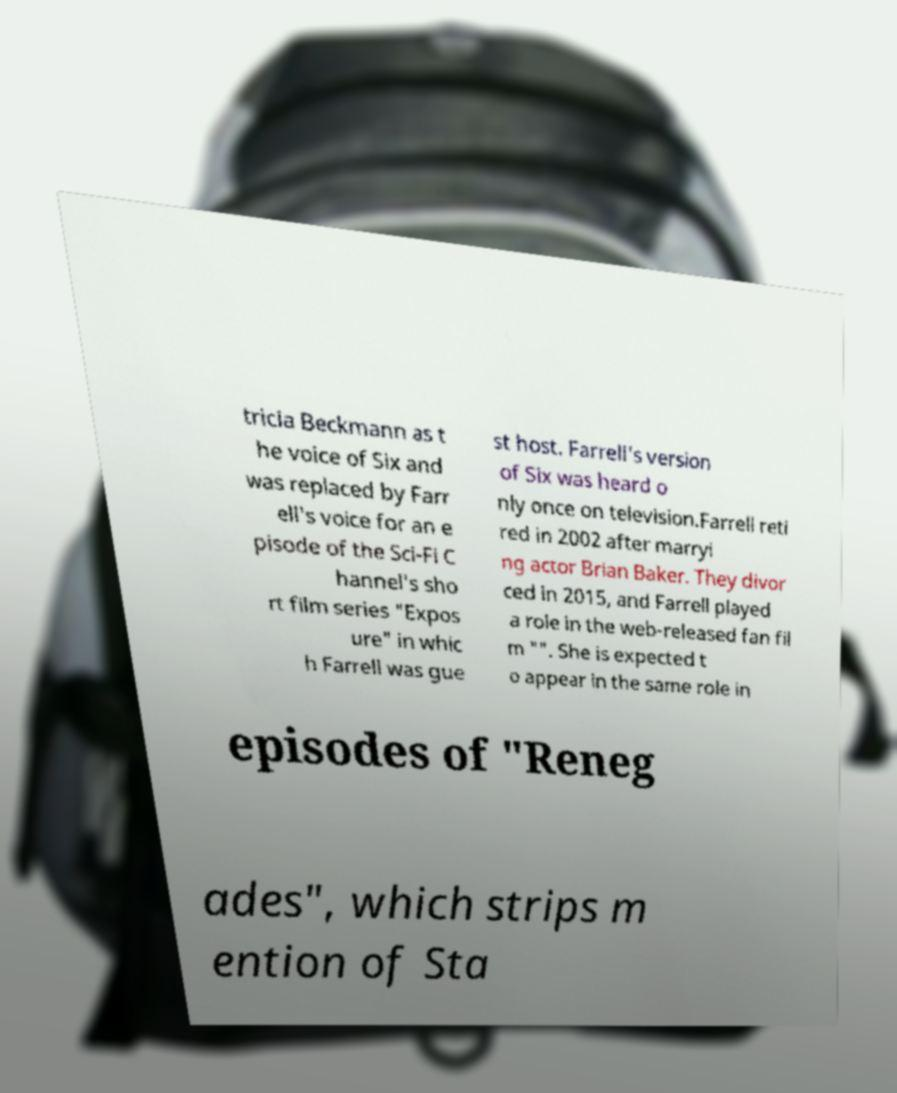Can you accurately transcribe the text from the provided image for me? tricia Beckmann as t he voice of Six and was replaced by Farr ell's voice for an e pisode of the Sci-Fi C hannel's sho rt film series "Expos ure" in whic h Farrell was gue st host. Farrell's version of Six was heard o nly once on television.Farrell reti red in 2002 after marryi ng actor Brian Baker. They divor ced in 2015, and Farrell played a role in the web-released fan fil m "". She is expected t o appear in the same role in episodes of "Reneg ades", which strips m ention of Sta 